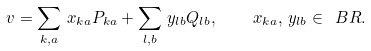<formula> <loc_0><loc_0><loc_500><loc_500>v = \sum _ { k , a } \, x _ { k a } P _ { k a } + \sum _ { l , b } \, y _ { l b } Q _ { l b } , \quad x _ { k a } , \, y _ { l b } \in \ B R .</formula> 